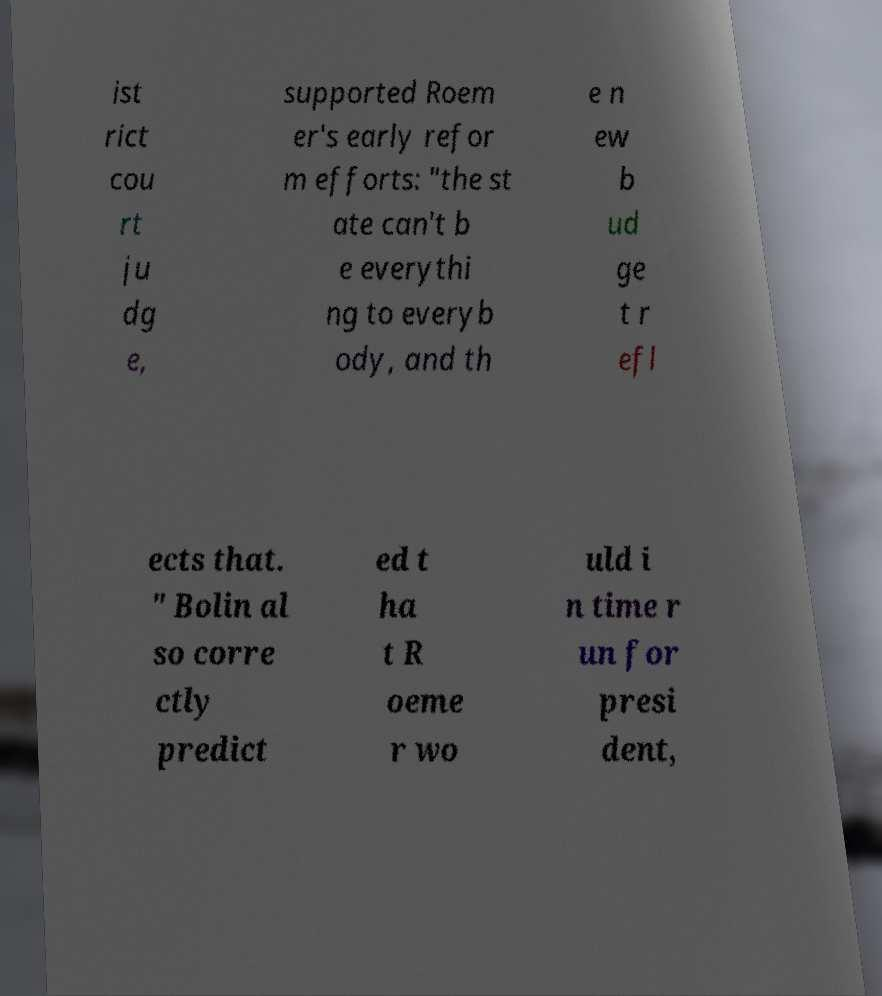Could you extract and type out the text from this image? ist rict cou rt ju dg e, supported Roem er's early refor m efforts: "the st ate can't b e everythi ng to everyb ody, and th e n ew b ud ge t r efl ects that. " Bolin al so corre ctly predict ed t ha t R oeme r wo uld i n time r un for presi dent, 